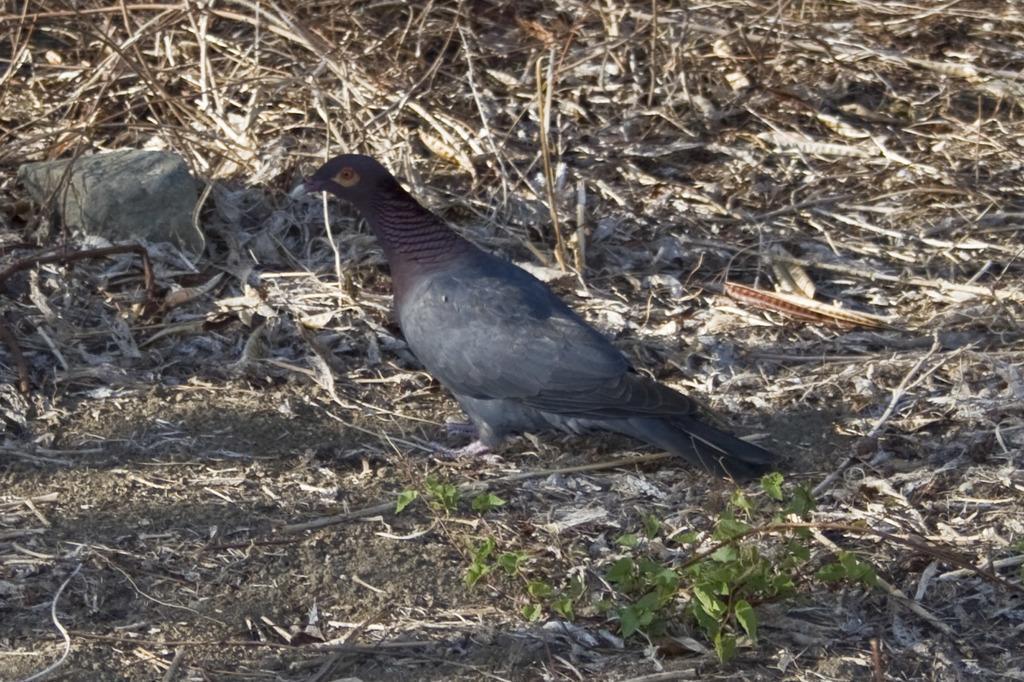In one or two sentences, can you explain what this image depicts? In this picture there is a bird in the center of the image and there are dry leaves and a stone on the ground. 